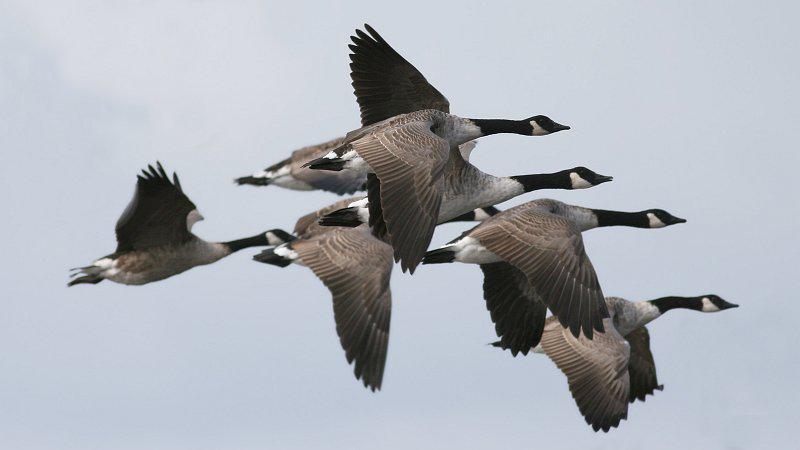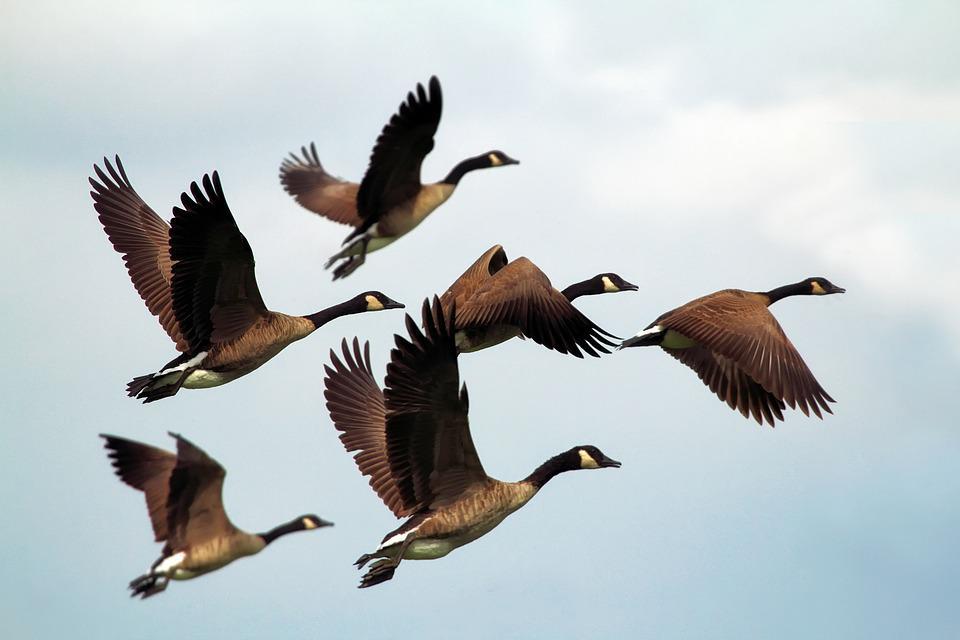The first image is the image on the left, the second image is the image on the right. Analyze the images presented: Is the assertion "The right image shows geese flying rightward in a V formation on a clear turquoise-blue sky." valid? Answer yes or no. No. 